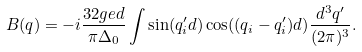Convert formula to latex. <formula><loc_0><loc_0><loc_500><loc_500>B ( { q } ) = - i \frac { 3 2 g e d } { \pi \Delta _ { 0 } } \int \sin ( q _ { i } ^ { \prime } d ) \cos ( ( q _ { i } - q _ { i } ^ { \prime } ) d ) \frac { d ^ { 3 } { q } ^ { \prime } } { ( 2 \pi ) ^ { 3 } } .</formula> 